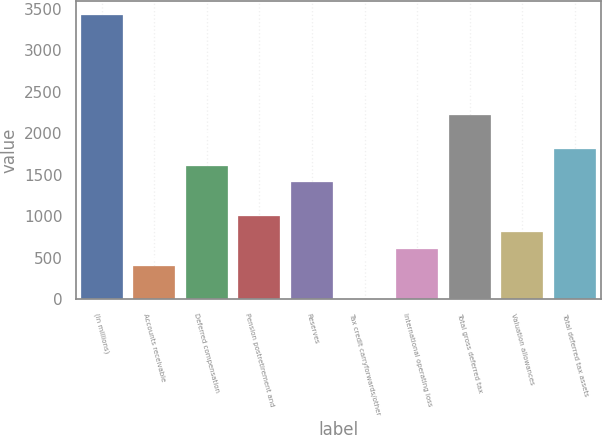Convert chart to OTSL. <chart><loc_0><loc_0><loc_500><loc_500><bar_chart><fcel>(In millions)<fcel>Accounts receivable<fcel>Deferred compensation<fcel>Pension postretirement and<fcel>Reserves<fcel>Tax credit carryforwards/other<fcel>International operating loss<fcel>Total gross deferred tax<fcel>Valuation allowances<fcel>Total deferred tax assets<nl><fcel>3419.56<fcel>403.36<fcel>1609.84<fcel>1006.6<fcel>1408.76<fcel>1.2<fcel>604.44<fcel>2213.08<fcel>805.52<fcel>1810.92<nl></chart> 